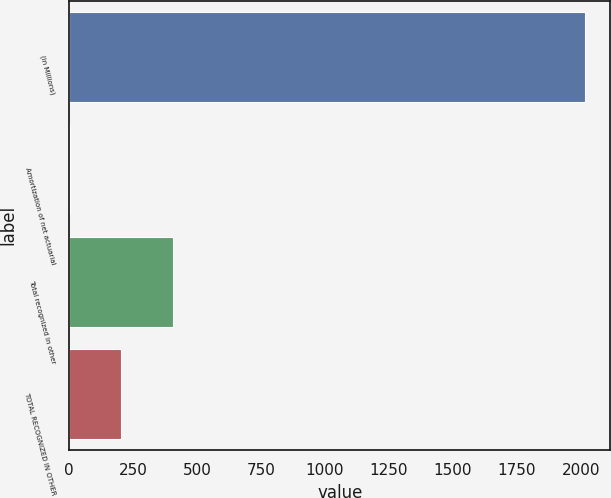Convert chart to OTSL. <chart><loc_0><loc_0><loc_500><loc_500><bar_chart><fcel>(in Millions)<fcel>Amortization of net actuarial<fcel>Total recognized in other<fcel>TOTAL RECOGNIZED IN OTHER<nl><fcel>2015<fcel>1.2<fcel>403.96<fcel>202.58<nl></chart> 